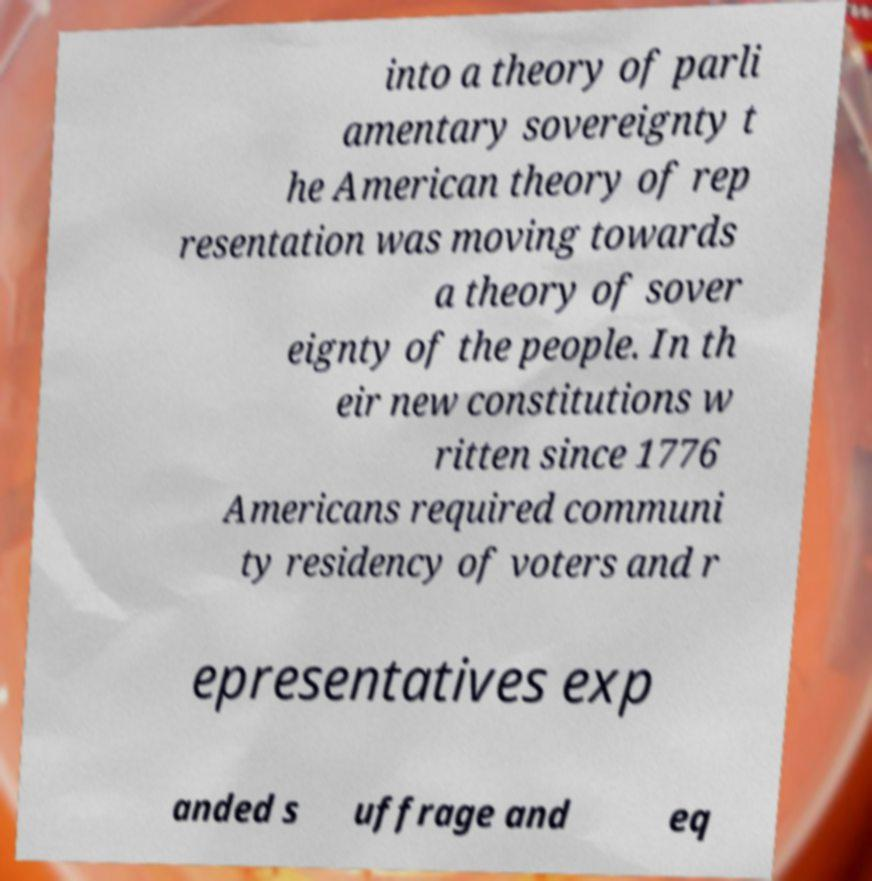Please read and relay the text visible in this image. What does it say? into a theory of parli amentary sovereignty t he American theory of rep resentation was moving towards a theory of sover eignty of the people. In th eir new constitutions w ritten since 1776 Americans required communi ty residency of voters and r epresentatives exp anded s uffrage and eq 